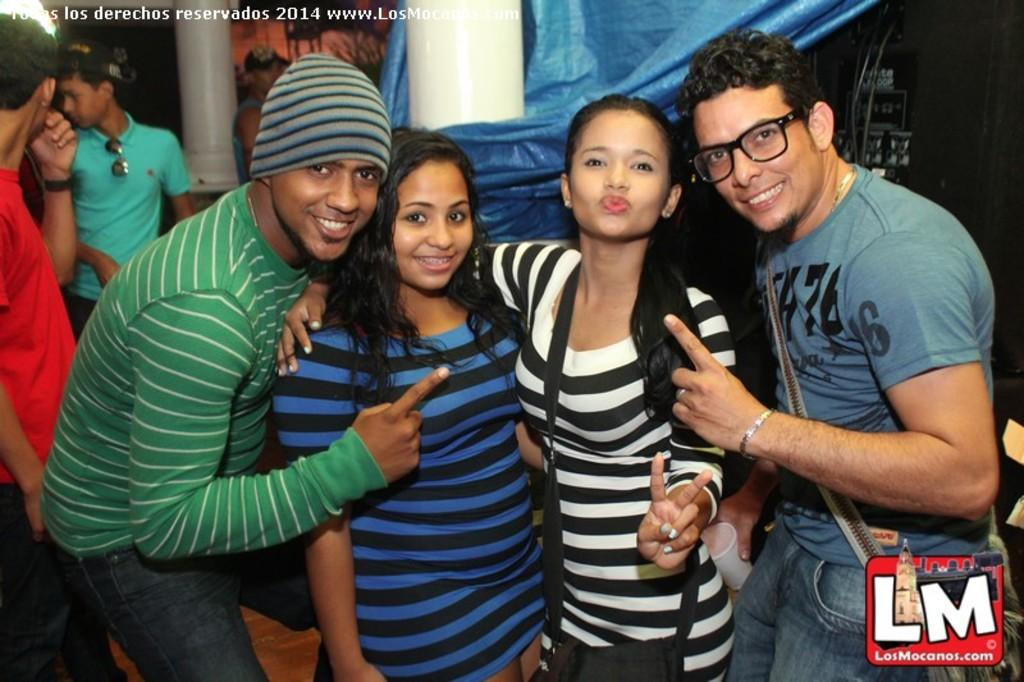How many people are in the image? There are three people in the image: two girls and a man. What are the girls doing in the image? The girls are standing and smiling in the middle of the image. What is the man doing in the image? The man is standing on the right side of the image and showing his left hand index finger. What can be observed about the man's appearance? The man is wearing spectacles and a t-shirt. What type of cat is sitting on the man's shoulder in the image? There is no cat present in the image; it only features two girls and a man. 